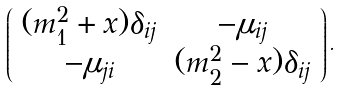<formula> <loc_0><loc_0><loc_500><loc_500>\left ( \begin{array} { c c } { { ( m _ { 1 } ^ { 2 } + x ) \delta _ { i j } } } & { { - \mu _ { i j } } } \\ { { - \mu _ { j i } } } & { { ( m _ { 2 } ^ { 2 } - x ) \delta _ { i j } } } \end{array} \right ) .</formula> 